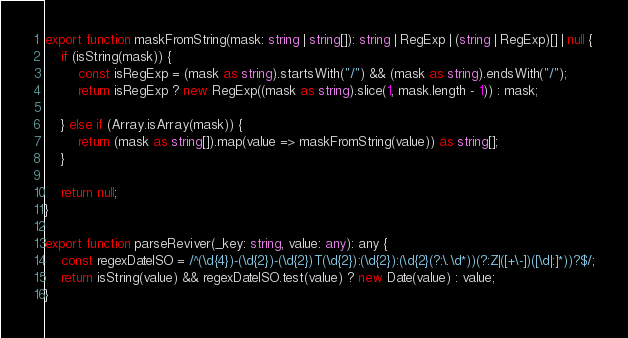Convert code to text. <code><loc_0><loc_0><loc_500><loc_500><_TypeScript_>
export function maskFromString(mask: string | string[]): string | RegExp | (string | RegExp)[] | null {
    if (isString(mask)) {
        const isRegExp = (mask as string).startsWith("/") && (mask as string).endsWith("/");
        return isRegExp ? new RegExp((mask as string).slice(1, mask.length - 1)) : mask;

    } else if (Array.isArray(mask)) {
        return (mask as string[]).map(value => maskFromString(value)) as string[];
    }

    return null;
}

export function parseReviver(_key: string, value: any): any {
    const regexDateISO = /^(\d{4})-(\d{2})-(\d{2})T(\d{2}):(\d{2}):(\d{2}(?:\.\d*))(?:Z|([+\-])([\d|:]*))?$/;
    return isString(value) && regexDateISO.test(value) ? new Date(value) : value;
}
</code> 